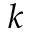Convert formula to latex. <formula><loc_0><loc_0><loc_500><loc_500>k</formula> 